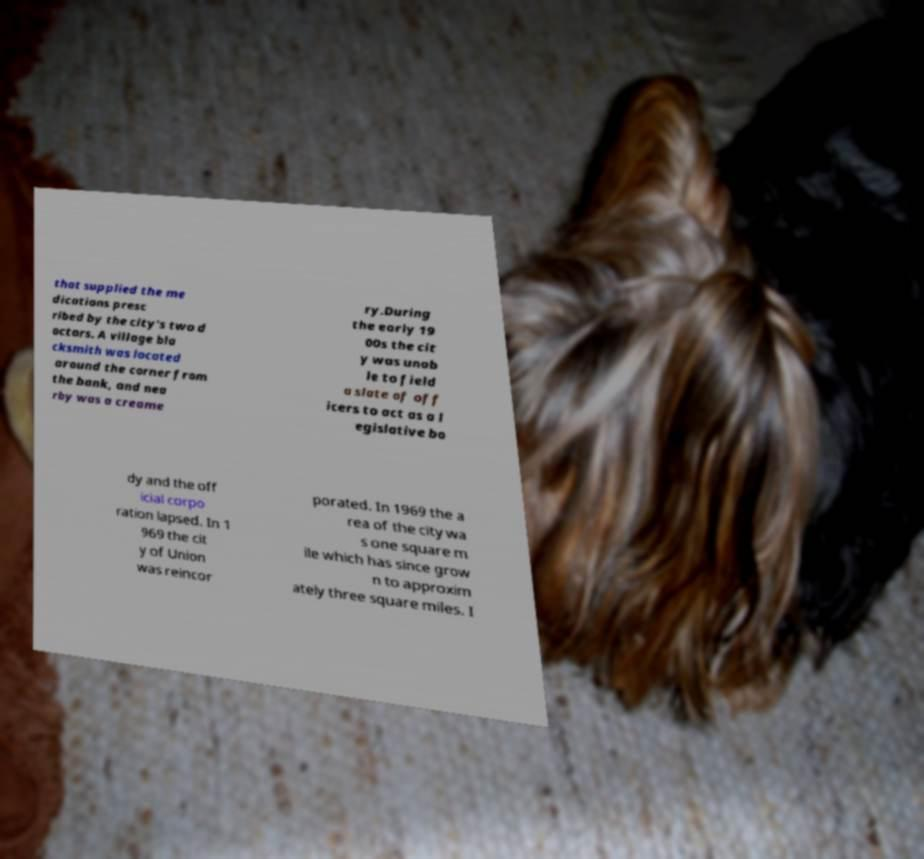Could you extract and type out the text from this image? that supplied the me dications presc ribed by the city's two d octors. A village bla cksmith was located around the corner from the bank, and nea rby was a creame ry.During the early 19 00s the cit y was unab le to field a slate of off icers to act as a l egislative bo dy and the off icial corpo ration lapsed. In 1 969 the cit y of Union was reincor porated. In 1969 the a rea of the city wa s one square m ile which has since grow n to approxim ately three square miles. I 